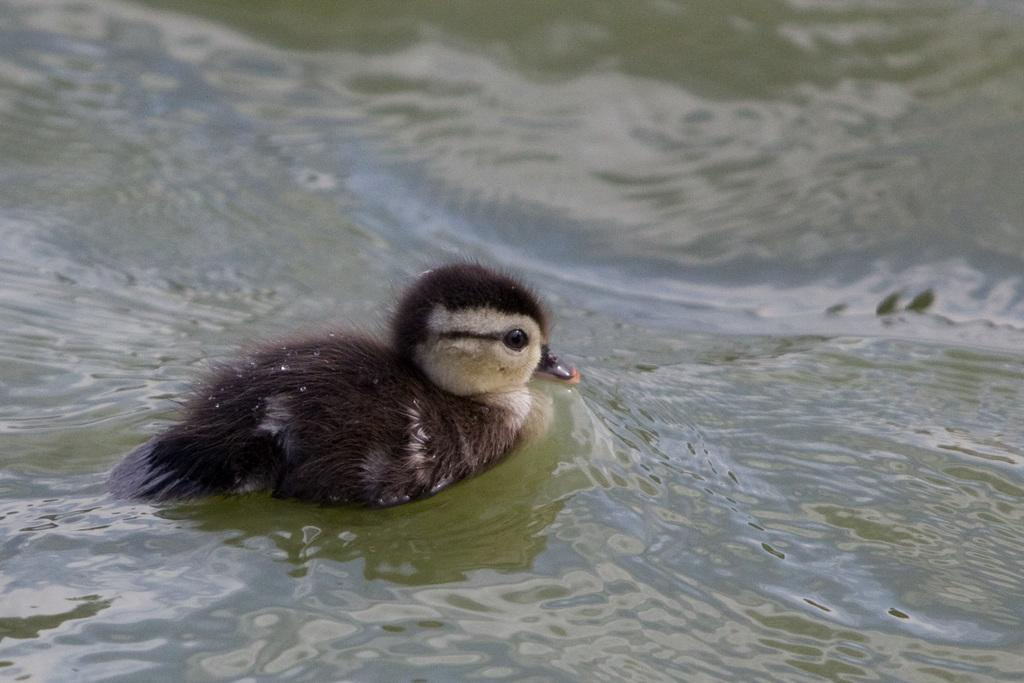What type of animal can be seen in the image? There is a bird in the water in the image. Can you describe the bird's location in the image? The bird is in the water in the image. What type of beef is being served on the throne in the image? There is no beef or throne present in the image; it features a bird in the water. 